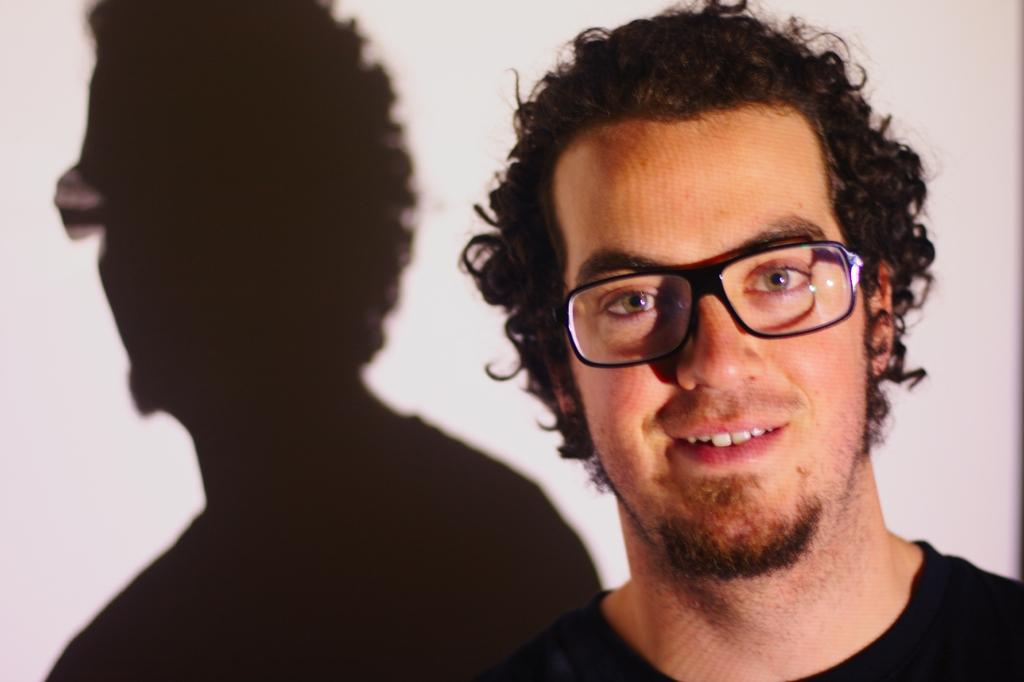Who is present in the image? There is a man in the image. What is the man wearing? The man is wearing clothes and spectacles. What is the man's facial expression? The man is smiling. What is the color of the background in the image? The background of the image is white. Can you describe any additional features of the man in the image? The shadow of the man is visible in the image. What type of cookware is the man using to cook in the image? There is no cookware or cooking activity present in the image. What idea does the man have in the image? The image does not provide any information about the man's ideas or thoughts. 